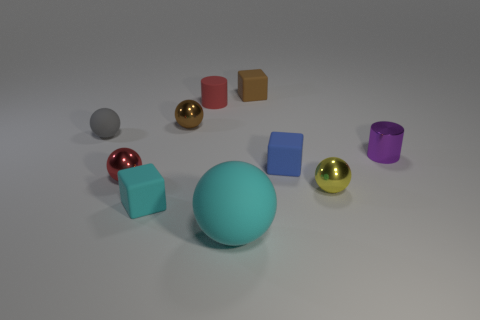Is the shape of the tiny gray object the same as the brown thing that is in front of the small red rubber object? The small gray object appears to be a sphere, and the brown object in question also has a spherical shape. Therefore, in terms of general shape, they do match as both exhibit the properties of a sphere, having a continuous surface where all points are equidistant from the center. 